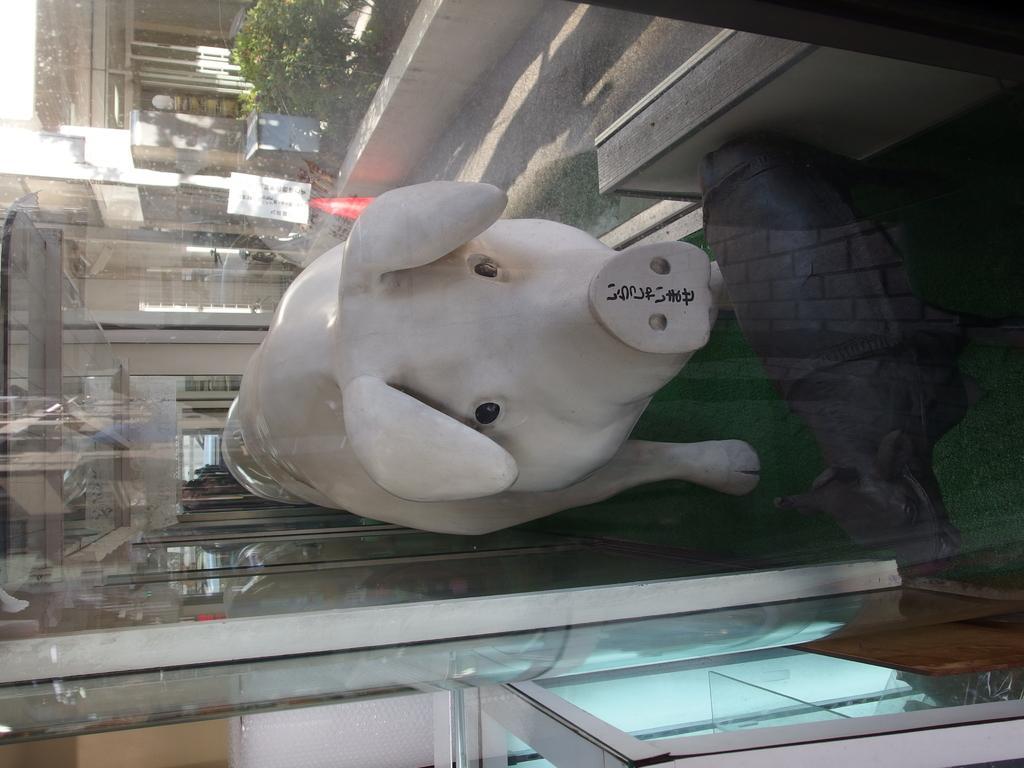Can you describe this image briefly? In this picture I can see two animal statues in the display box. 